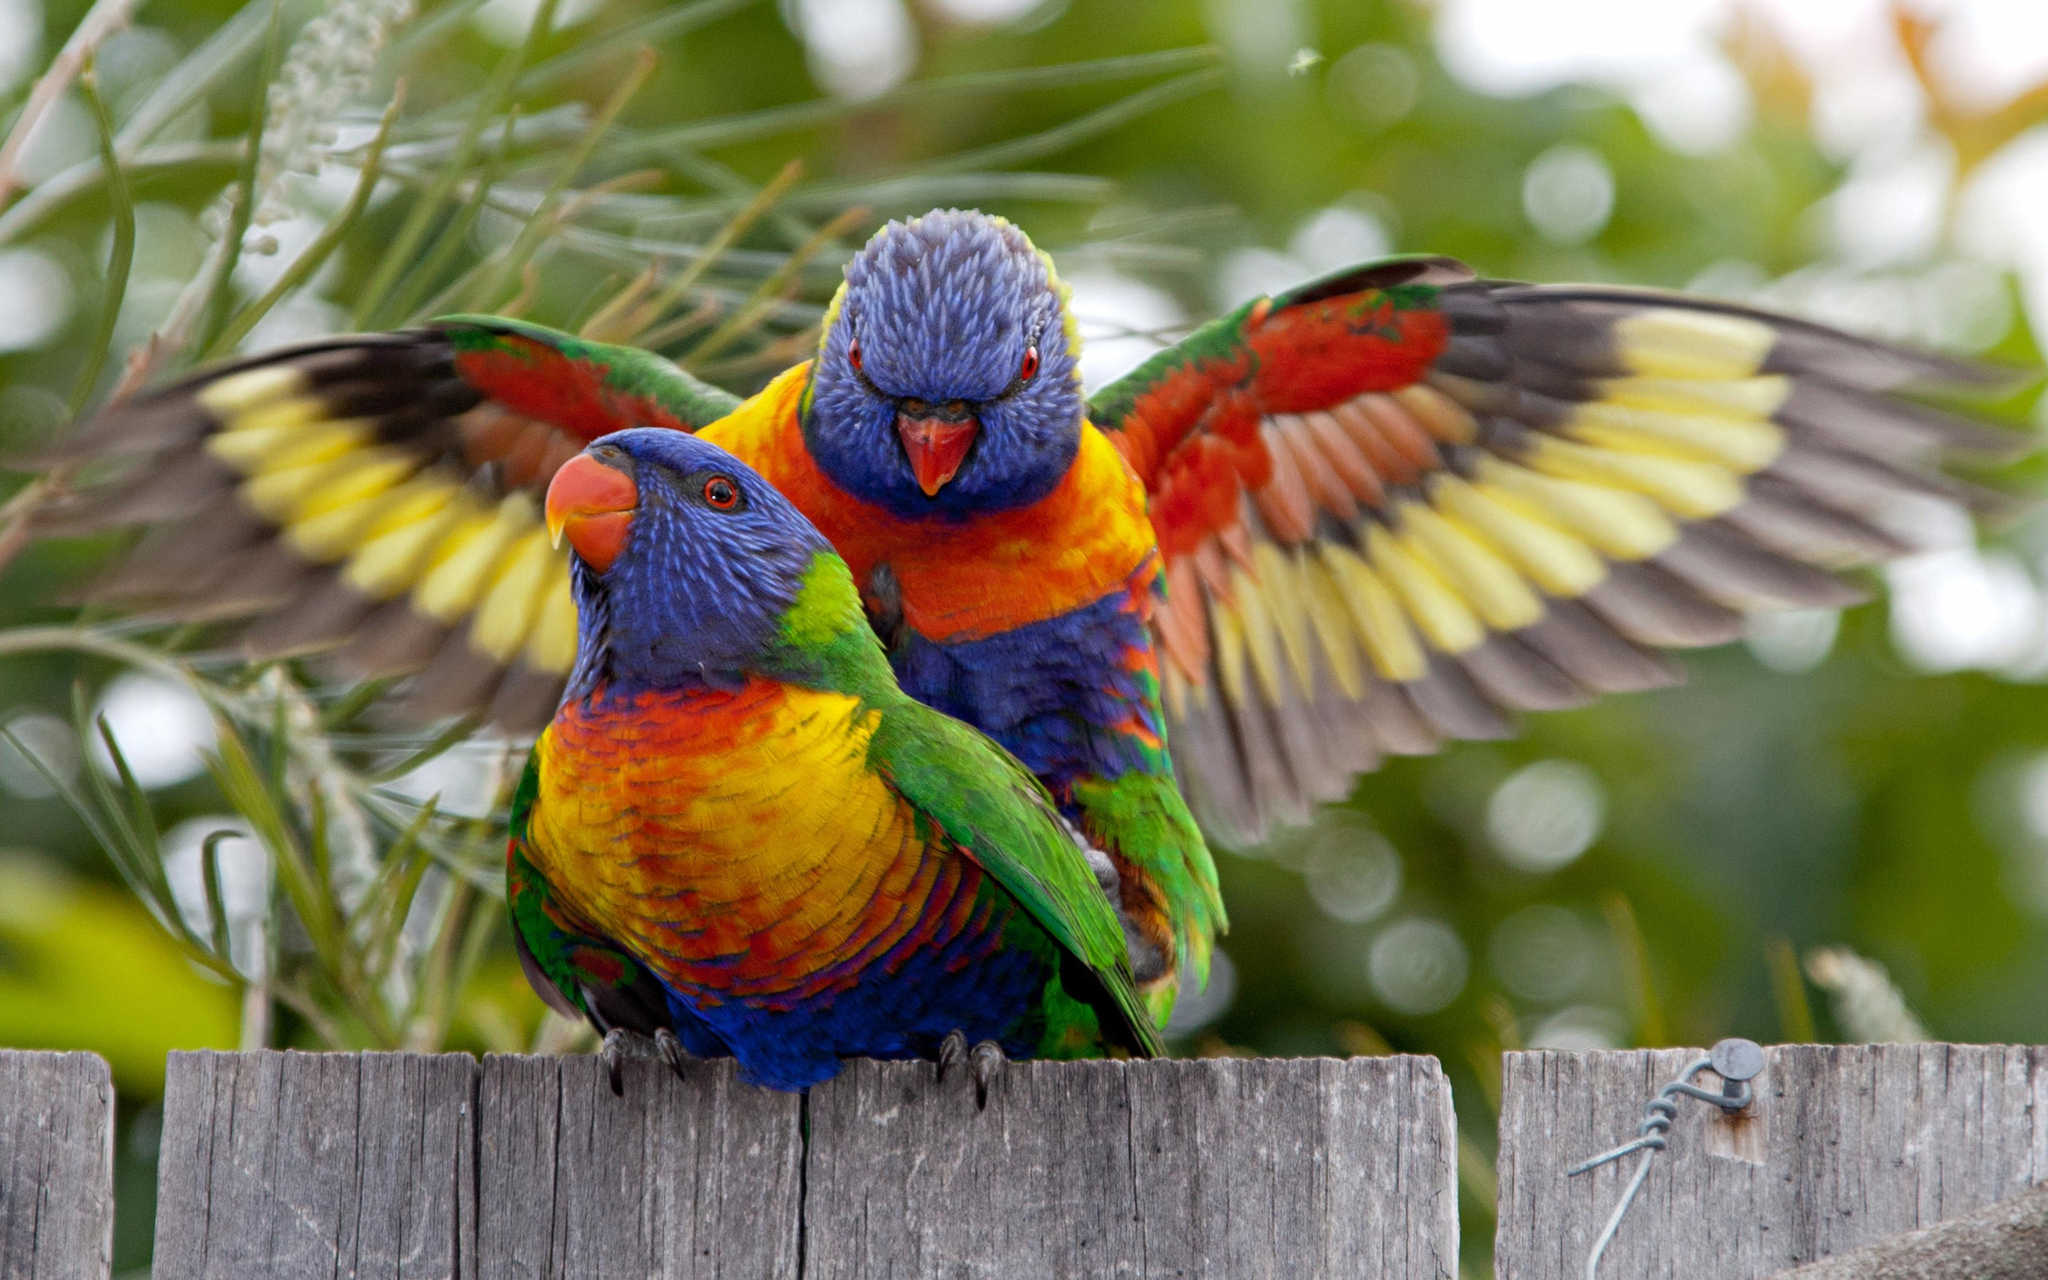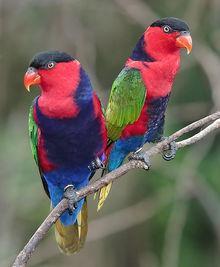The first image is the image on the left, the second image is the image on the right. Examine the images to the left and right. Is the description "There are two birds in each image." accurate? Answer yes or no. Yes. The first image is the image on the left, the second image is the image on the right. Analyze the images presented: Is the assertion "the right image has two birds next to each other on a branch" valid? Answer yes or no. Yes. 